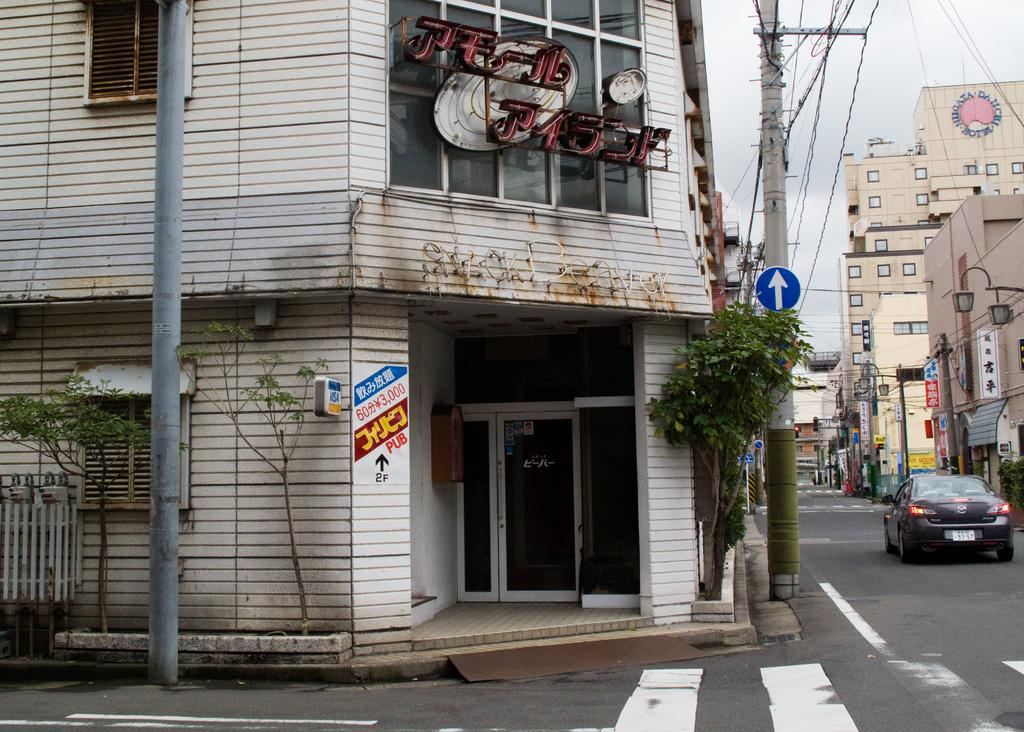What structures are present in the image? There are poles, buildings, and hoardings in the image. What type of vegetation can be seen in the image? There are trees in the image. What is the car's location in the image? The car is on the right side of the image and on the road. What can be seen in the background of the image? There are lights visible in the background of the image. Can you tell me how many times the plastic was kicked in the image? There is no plastic or kicking activity present in the image. What type of start can be seen in the image? There is no start or any related activity depicted in the image. 